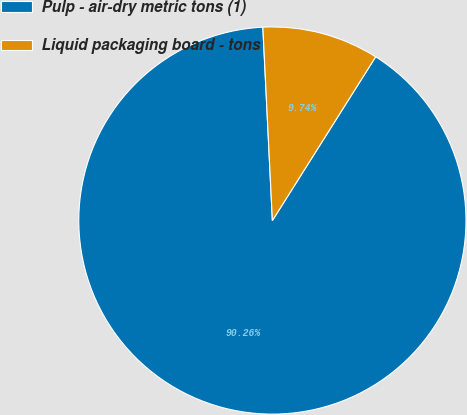Convert chart. <chart><loc_0><loc_0><loc_500><loc_500><pie_chart><fcel>Pulp - air-dry metric tons (1)<fcel>Liquid packaging board - tons<nl><fcel>90.26%<fcel>9.74%<nl></chart> 